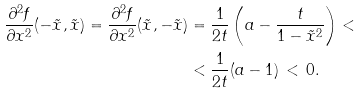<formula> <loc_0><loc_0><loc_500><loc_500>\frac { \partial ^ { 2 } f } { \partial x ^ { 2 } } ( - \tilde { x } , \tilde { x } ) = \frac { \partial ^ { 2 } f } { \partial x ^ { 2 } } ( \tilde { x } , - \tilde { x } ) & = \frac { 1 } { 2 t } \left ( a - \frac { t } { 1 - \tilde { x } ^ { 2 } } \right ) < \\ & < \frac { 1 } { 2 t } ( a - 1 ) \, < \, 0 .</formula> 